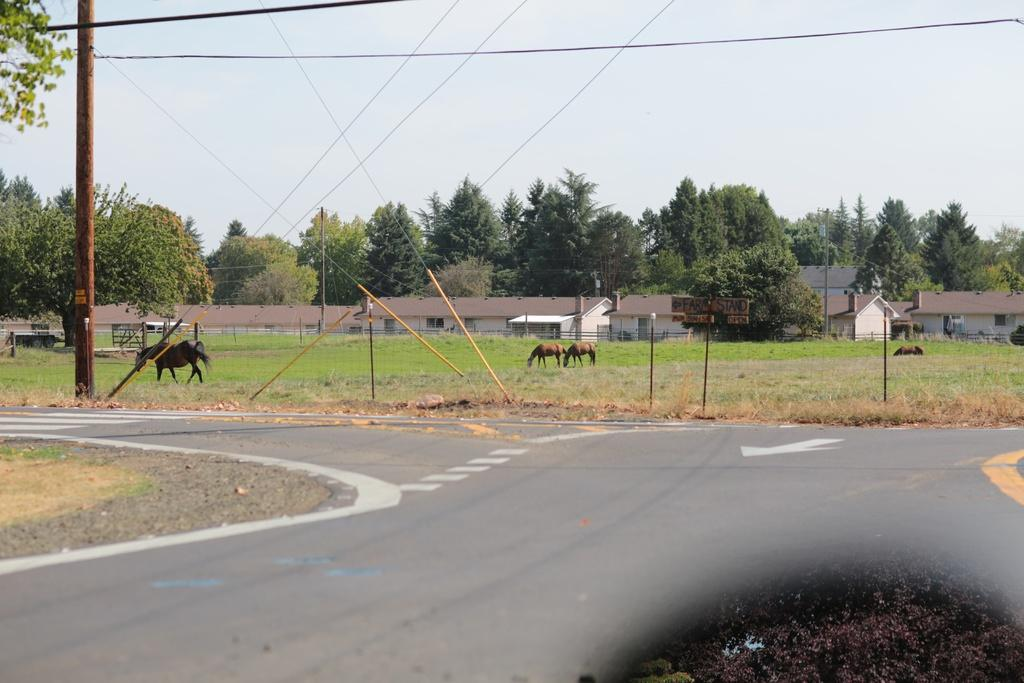What animals can be seen in the image? There are horses in the image. What are the horses doing? The horses are grazing. What type of infrastructure is present in the image? There is a road, electric poles, and electric cables visible in the image. What type of natural elements can be seen in the image? Trees and the sky are visible in the image. What type of man-made structures are present in the image? There are buildings in the image. What type of connection can be seen between the horses and the guide in the image? There is no guide present in the image, and therefore no connection between the horses and a guide can be observed. 